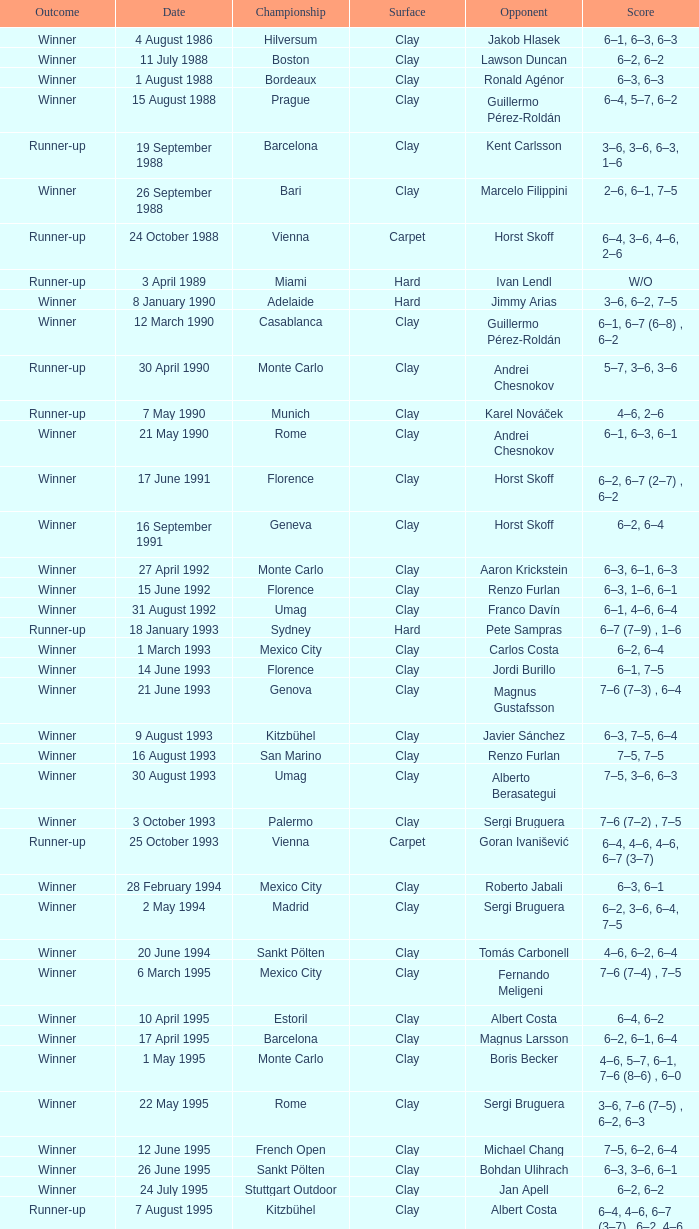What is the score when the outcome is victor against yevgeny kafelnikov? 6–2, 6–2, 6–4. 